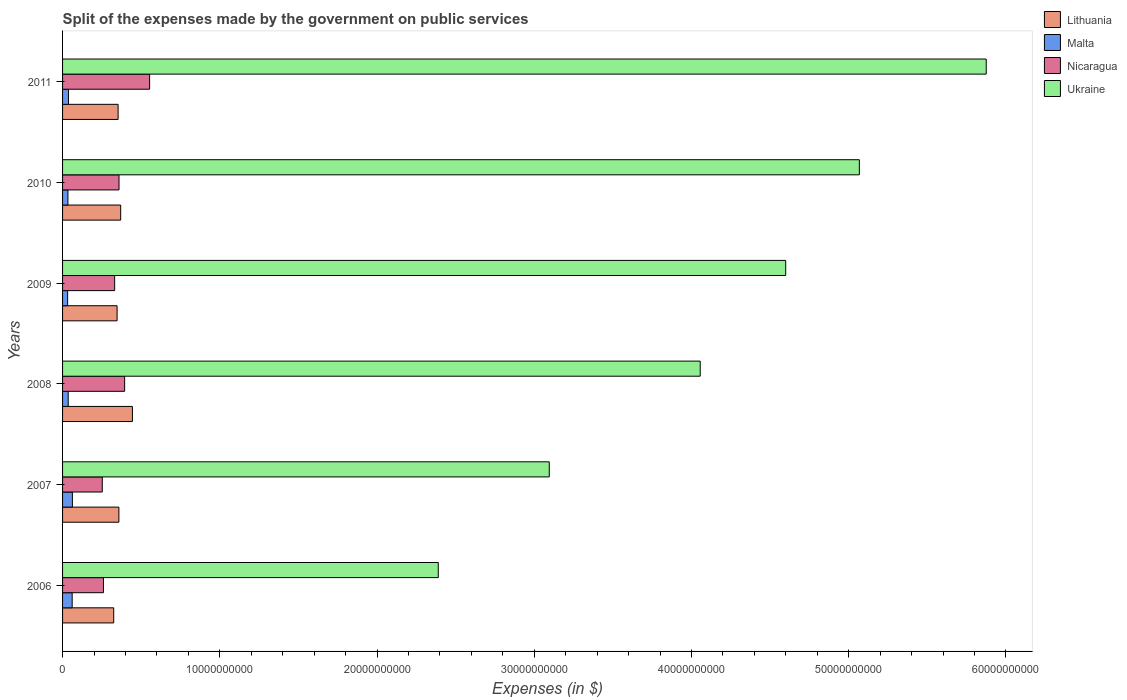How many different coloured bars are there?
Give a very brief answer. 4. Are the number of bars on each tick of the Y-axis equal?
Your answer should be compact. Yes. How many bars are there on the 2nd tick from the top?
Offer a very short reply. 4. What is the label of the 2nd group of bars from the top?
Offer a terse response. 2010. In how many cases, is the number of bars for a given year not equal to the number of legend labels?
Offer a terse response. 0. What is the expenses made by the government on public services in Lithuania in 2007?
Keep it short and to the point. 3.58e+09. Across all years, what is the maximum expenses made by the government on public services in Lithuania?
Provide a short and direct response. 4.44e+09. Across all years, what is the minimum expenses made by the government on public services in Lithuania?
Your answer should be compact. 3.25e+09. In which year was the expenses made by the government on public services in Lithuania minimum?
Offer a very short reply. 2006. What is the total expenses made by the government on public services in Malta in the graph?
Ensure brevity in your answer.  2.63e+09. What is the difference between the expenses made by the government on public services in Ukraine in 2008 and that in 2010?
Provide a short and direct response. -1.01e+1. What is the difference between the expenses made by the government on public services in Lithuania in 2010 and the expenses made by the government on public services in Malta in 2009?
Keep it short and to the point. 3.37e+09. What is the average expenses made by the government on public services in Nicaragua per year?
Provide a succinct answer. 3.59e+09. In the year 2007, what is the difference between the expenses made by the government on public services in Ukraine and expenses made by the government on public services in Malta?
Your answer should be very brief. 3.03e+1. In how many years, is the expenses made by the government on public services in Ukraine greater than 28000000000 $?
Your answer should be very brief. 5. What is the ratio of the expenses made by the government on public services in Ukraine in 2010 to that in 2011?
Ensure brevity in your answer.  0.86. Is the difference between the expenses made by the government on public services in Ukraine in 2010 and 2011 greater than the difference between the expenses made by the government on public services in Malta in 2010 and 2011?
Keep it short and to the point. No. What is the difference between the highest and the second highest expenses made by the government on public services in Nicaragua?
Ensure brevity in your answer.  1.59e+09. What is the difference between the highest and the lowest expenses made by the government on public services in Ukraine?
Ensure brevity in your answer.  3.49e+1. Is the sum of the expenses made by the government on public services in Nicaragua in 2010 and 2011 greater than the maximum expenses made by the government on public services in Malta across all years?
Make the answer very short. Yes. Is it the case that in every year, the sum of the expenses made by the government on public services in Lithuania and expenses made by the government on public services in Nicaragua is greater than the sum of expenses made by the government on public services in Ukraine and expenses made by the government on public services in Malta?
Keep it short and to the point. Yes. What does the 3rd bar from the top in 2007 represents?
Your response must be concise. Malta. What does the 3rd bar from the bottom in 2008 represents?
Ensure brevity in your answer.  Nicaragua. Is it the case that in every year, the sum of the expenses made by the government on public services in Nicaragua and expenses made by the government on public services in Malta is greater than the expenses made by the government on public services in Lithuania?
Offer a terse response. No. How many bars are there?
Provide a succinct answer. 24. Are all the bars in the graph horizontal?
Ensure brevity in your answer.  Yes. How many years are there in the graph?
Your answer should be very brief. 6. What is the difference between two consecutive major ticks on the X-axis?
Provide a succinct answer. 1.00e+1. Does the graph contain any zero values?
Your response must be concise. No. Does the graph contain grids?
Keep it short and to the point. No. How are the legend labels stacked?
Your answer should be compact. Vertical. What is the title of the graph?
Provide a succinct answer. Split of the expenses made by the government on public services. Does "Poland" appear as one of the legend labels in the graph?
Provide a short and direct response. No. What is the label or title of the X-axis?
Make the answer very short. Expenses (in $). What is the label or title of the Y-axis?
Provide a succinct answer. Years. What is the Expenses (in $) in Lithuania in 2006?
Offer a very short reply. 3.25e+09. What is the Expenses (in $) in Malta in 2006?
Keep it short and to the point. 6.11e+08. What is the Expenses (in $) of Nicaragua in 2006?
Keep it short and to the point. 2.60e+09. What is the Expenses (in $) in Ukraine in 2006?
Offer a terse response. 2.39e+1. What is the Expenses (in $) of Lithuania in 2007?
Offer a terse response. 3.58e+09. What is the Expenses (in $) in Malta in 2007?
Offer a very short reply. 6.25e+08. What is the Expenses (in $) in Nicaragua in 2007?
Your response must be concise. 2.53e+09. What is the Expenses (in $) of Ukraine in 2007?
Give a very brief answer. 3.10e+1. What is the Expenses (in $) in Lithuania in 2008?
Offer a terse response. 4.44e+09. What is the Expenses (in $) in Malta in 2008?
Ensure brevity in your answer.  3.59e+08. What is the Expenses (in $) of Nicaragua in 2008?
Keep it short and to the point. 3.95e+09. What is the Expenses (in $) of Ukraine in 2008?
Provide a succinct answer. 4.06e+1. What is the Expenses (in $) of Lithuania in 2009?
Your response must be concise. 3.47e+09. What is the Expenses (in $) in Malta in 2009?
Your answer should be very brief. 3.22e+08. What is the Expenses (in $) in Nicaragua in 2009?
Offer a very short reply. 3.31e+09. What is the Expenses (in $) of Ukraine in 2009?
Keep it short and to the point. 4.60e+1. What is the Expenses (in $) of Lithuania in 2010?
Provide a short and direct response. 3.70e+09. What is the Expenses (in $) of Malta in 2010?
Ensure brevity in your answer.  3.41e+08. What is the Expenses (in $) in Nicaragua in 2010?
Offer a very short reply. 3.59e+09. What is the Expenses (in $) of Ukraine in 2010?
Give a very brief answer. 5.07e+1. What is the Expenses (in $) of Lithuania in 2011?
Offer a terse response. 3.53e+09. What is the Expenses (in $) in Malta in 2011?
Offer a terse response. 3.76e+08. What is the Expenses (in $) of Nicaragua in 2011?
Your answer should be very brief. 5.54e+09. What is the Expenses (in $) of Ukraine in 2011?
Your answer should be very brief. 5.87e+1. Across all years, what is the maximum Expenses (in $) of Lithuania?
Make the answer very short. 4.44e+09. Across all years, what is the maximum Expenses (in $) of Malta?
Keep it short and to the point. 6.25e+08. Across all years, what is the maximum Expenses (in $) in Nicaragua?
Your answer should be compact. 5.54e+09. Across all years, what is the maximum Expenses (in $) of Ukraine?
Make the answer very short. 5.87e+1. Across all years, what is the minimum Expenses (in $) in Lithuania?
Your response must be concise. 3.25e+09. Across all years, what is the minimum Expenses (in $) in Malta?
Your answer should be compact. 3.22e+08. Across all years, what is the minimum Expenses (in $) of Nicaragua?
Your response must be concise. 2.53e+09. Across all years, what is the minimum Expenses (in $) in Ukraine?
Make the answer very short. 2.39e+1. What is the total Expenses (in $) in Lithuania in the graph?
Provide a short and direct response. 2.20e+1. What is the total Expenses (in $) in Malta in the graph?
Make the answer very short. 2.63e+09. What is the total Expenses (in $) in Nicaragua in the graph?
Your answer should be compact. 2.15e+1. What is the total Expenses (in $) in Ukraine in the graph?
Provide a succinct answer. 2.51e+11. What is the difference between the Expenses (in $) of Lithuania in 2006 and that in 2007?
Your response must be concise. -3.29e+08. What is the difference between the Expenses (in $) in Malta in 2006 and that in 2007?
Provide a short and direct response. -1.40e+07. What is the difference between the Expenses (in $) in Nicaragua in 2006 and that in 2007?
Provide a short and direct response. 7.43e+07. What is the difference between the Expenses (in $) of Ukraine in 2006 and that in 2007?
Give a very brief answer. -7.06e+09. What is the difference between the Expenses (in $) in Lithuania in 2006 and that in 2008?
Keep it short and to the point. -1.19e+09. What is the difference between the Expenses (in $) of Malta in 2006 and that in 2008?
Your answer should be compact. 2.52e+08. What is the difference between the Expenses (in $) in Nicaragua in 2006 and that in 2008?
Your response must be concise. -1.35e+09. What is the difference between the Expenses (in $) in Ukraine in 2006 and that in 2008?
Offer a terse response. -1.67e+1. What is the difference between the Expenses (in $) of Lithuania in 2006 and that in 2009?
Your answer should be compact. -2.15e+08. What is the difference between the Expenses (in $) in Malta in 2006 and that in 2009?
Give a very brief answer. 2.89e+08. What is the difference between the Expenses (in $) in Nicaragua in 2006 and that in 2009?
Give a very brief answer. -7.12e+08. What is the difference between the Expenses (in $) in Ukraine in 2006 and that in 2009?
Offer a very short reply. -2.21e+1. What is the difference between the Expenses (in $) in Lithuania in 2006 and that in 2010?
Give a very brief answer. -4.43e+08. What is the difference between the Expenses (in $) of Malta in 2006 and that in 2010?
Ensure brevity in your answer.  2.70e+08. What is the difference between the Expenses (in $) in Nicaragua in 2006 and that in 2010?
Provide a short and direct response. -9.89e+08. What is the difference between the Expenses (in $) of Ukraine in 2006 and that in 2010?
Provide a short and direct response. -2.68e+1. What is the difference between the Expenses (in $) of Lithuania in 2006 and that in 2011?
Ensure brevity in your answer.  -2.79e+08. What is the difference between the Expenses (in $) in Malta in 2006 and that in 2011?
Give a very brief answer. 2.35e+08. What is the difference between the Expenses (in $) of Nicaragua in 2006 and that in 2011?
Make the answer very short. -2.94e+09. What is the difference between the Expenses (in $) of Ukraine in 2006 and that in 2011?
Provide a short and direct response. -3.49e+1. What is the difference between the Expenses (in $) in Lithuania in 2007 and that in 2008?
Your answer should be very brief. -8.61e+08. What is the difference between the Expenses (in $) in Malta in 2007 and that in 2008?
Provide a succinct answer. 2.66e+08. What is the difference between the Expenses (in $) in Nicaragua in 2007 and that in 2008?
Keep it short and to the point. -1.42e+09. What is the difference between the Expenses (in $) in Ukraine in 2007 and that in 2008?
Offer a very short reply. -9.60e+09. What is the difference between the Expenses (in $) in Lithuania in 2007 and that in 2009?
Ensure brevity in your answer.  1.14e+08. What is the difference between the Expenses (in $) in Malta in 2007 and that in 2009?
Your answer should be very brief. 3.03e+08. What is the difference between the Expenses (in $) in Nicaragua in 2007 and that in 2009?
Ensure brevity in your answer.  -7.87e+08. What is the difference between the Expenses (in $) of Ukraine in 2007 and that in 2009?
Your response must be concise. -1.50e+1. What is the difference between the Expenses (in $) in Lithuania in 2007 and that in 2010?
Your answer should be very brief. -1.14e+08. What is the difference between the Expenses (in $) of Malta in 2007 and that in 2010?
Your answer should be compact. 2.84e+08. What is the difference between the Expenses (in $) of Nicaragua in 2007 and that in 2010?
Offer a terse response. -1.06e+09. What is the difference between the Expenses (in $) of Ukraine in 2007 and that in 2010?
Ensure brevity in your answer.  -1.97e+1. What is the difference between the Expenses (in $) in Lithuania in 2007 and that in 2011?
Provide a short and direct response. 4.96e+07. What is the difference between the Expenses (in $) in Malta in 2007 and that in 2011?
Offer a very short reply. 2.49e+08. What is the difference between the Expenses (in $) in Nicaragua in 2007 and that in 2011?
Make the answer very short. -3.01e+09. What is the difference between the Expenses (in $) in Ukraine in 2007 and that in 2011?
Provide a succinct answer. -2.78e+1. What is the difference between the Expenses (in $) of Lithuania in 2008 and that in 2009?
Provide a succinct answer. 9.76e+08. What is the difference between the Expenses (in $) in Malta in 2008 and that in 2009?
Give a very brief answer. 3.69e+07. What is the difference between the Expenses (in $) in Nicaragua in 2008 and that in 2009?
Keep it short and to the point. 6.34e+08. What is the difference between the Expenses (in $) in Ukraine in 2008 and that in 2009?
Give a very brief answer. -5.44e+09. What is the difference between the Expenses (in $) of Lithuania in 2008 and that in 2010?
Make the answer very short. 7.47e+08. What is the difference between the Expenses (in $) of Malta in 2008 and that in 2010?
Keep it short and to the point. 1.82e+07. What is the difference between the Expenses (in $) in Nicaragua in 2008 and that in 2010?
Keep it short and to the point. 3.57e+08. What is the difference between the Expenses (in $) in Ukraine in 2008 and that in 2010?
Provide a short and direct response. -1.01e+1. What is the difference between the Expenses (in $) of Lithuania in 2008 and that in 2011?
Provide a short and direct response. 9.11e+08. What is the difference between the Expenses (in $) in Malta in 2008 and that in 2011?
Make the answer very short. -1.72e+07. What is the difference between the Expenses (in $) in Nicaragua in 2008 and that in 2011?
Your response must be concise. -1.59e+09. What is the difference between the Expenses (in $) in Ukraine in 2008 and that in 2011?
Give a very brief answer. -1.82e+1. What is the difference between the Expenses (in $) in Lithuania in 2009 and that in 2010?
Keep it short and to the point. -2.29e+08. What is the difference between the Expenses (in $) of Malta in 2009 and that in 2010?
Provide a succinct answer. -1.87e+07. What is the difference between the Expenses (in $) of Nicaragua in 2009 and that in 2010?
Ensure brevity in your answer.  -2.77e+08. What is the difference between the Expenses (in $) of Ukraine in 2009 and that in 2010?
Offer a very short reply. -4.68e+09. What is the difference between the Expenses (in $) of Lithuania in 2009 and that in 2011?
Your response must be concise. -6.47e+07. What is the difference between the Expenses (in $) in Malta in 2009 and that in 2011?
Your response must be concise. -5.41e+07. What is the difference between the Expenses (in $) in Nicaragua in 2009 and that in 2011?
Ensure brevity in your answer.  -2.22e+09. What is the difference between the Expenses (in $) of Ukraine in 2009 and that in 2011?
Your response must be concise. -1.28e+1. What is the difference between the Expenses (in $) in Lithuania in 2010 and that in 2011?
Provide a short and direct response. 1.64e+08. What is the difference between the Expenses (in $) of Malta in 2010 and that in 2011?
Offer a terse response. -3.53e+07. What is the difference between the Expenses (in $) of Nicaragua in 2010 and that in 2011?
Give a very brief answer. -1.95e+09. What is the difference between the Expenses (in $) of Ukraine in 2010 and that in 2011?
Your response must be concise. -8.07e+09. What is the difference between the Expenses (in $) in Lithuania in 2006 and the Expenses (in $) in Malta in 2007?
Offer a terse response. 2.63e+09. What is the difference between the Expenses (in $) in Lithuania in 2006 and the Expenses (in $) in Nicaragua in 2007?
Give a very brief answer. 7.27e+08. What is the difference between the Expenses (in $) of Lithuania in 2006 and the Expenses (in $) of Ukraine in 2007?
Keep it short and to the point. -2.77e+1. What is the difference between the Expenses (in $) in Malta in 2006 and the Expenses (in $) in Nicaragua in 2007?
Provide a succinct answer. -1.92e+09. What is the difference between the Expenses (in $) in Malta in 2006 and the Expenses (in $) in Ukraine in 2007?
Your response must be concise. -3.03e+1. What is the difference between the Expenses (in $) of Nicaragua in 2006 and the Expenses (in $) of Ukraine in 2007?
Your answer should be compact. -2.84e+1. What is the difference between the Expenses (in $) in Lithuania in 2006 and the Expenses (in $) in Malta in 2008?
Provide a short and direct response. 2.89e+09. What is the difference between the Expenses (in $) in Lithuania in 2006 and the Expenses (in $) in Nicaragua in 2008?
Your answer should be compact. -6.94e+08. What is the difference between the Expenses (in $) in Lithuania in 2006 and the Expenses (in $) in Ukraine in 2008?
Provide a succinct answer. -3.73e+1. What is the difference between the Expenses (in $) of Malta in 2006 and the Expenses (in $) of Nicaragua in 2008?
Make the answer very short. -3.34e+09. What is the difference between the Expenses (in $) of Malta in 2006 and the Expenses (in $) of Ukraine in 2008?
Your answer should be very brief. -3.99e+1. What is the difference between the Expenses (in $) of Nicaragua in 2006 and the Expenses (in $) of Ukraine in 2008?
Give a very brief answer. -3.80e+1. What is the difference between the Expenses (in $) of Lithuania in 2006 and the Expenses (in $) of Malta in 2009?
Your response must be concise. 2.93e+09. What is the difference between the Expenses (in $) of Lithuania in 2006 and the Expenses (in $) of Nicaragua in 2009?
Your response must be concise. -5.99e+07. What is the difference between the Expenses (in $) of Lithuania in 2006 and the Expenses (in $) of Ukraine in 2009?
Ensure brevity in your answer.  -4.27e+1. What is the difference between the Expenses (in $) in Malta in 2006 and the Expenses (in $) in Nicaragua in 2009?
Your response must be concise. -2.70e+09. What is the difference between the Expenses (in $) of Malta in 2006 and the Expenses (in $) of Ukraine in 2009?
Provide a succinct answer. -4.54e+1. What is the difference between the Expenses (in $) of Nicaragua in 2006 and the Expenses (in $) of Ukraine in 2009?
Keep it short and to the point. -4.34e+1. What is the difference between the Expenses (in $) of Lithuania in 2006 and the Expenses (in $) of Malta in 2010?
Provide a short and direct response. 2.91e+09. What is the difference between the Expenses (in $) in Lithuania in 2006 and the Expenses (in $) in Nicaragua in 2010?
Give a very brief answer. -3.37e+08. What is the difference between the Expenses (in $) in Lithuania in 2006 and the Expenses (in $) in Ukraine in 2010?
Provide a short and direct response. -4.74e+1. What is the difference between the Expenses (in $) of Malta in 2006 and the Expenses (in $) of Nicaragua in 2010?
Offer a very short reply. -2.98e+09. What is the difference between the Expenses (in $) in Malta in 2006 and the Expenses (in $) in Ukraine in 2010?
Offer a terse response. -5.01e+1. What is the difference between the Expenses (in $) of Nicaragua in 2006 and the Expenses (in $) of Ukraine in 2010?
Your answer should be compact. -4.81e+1. What is the difference between the Expenses (in $) of Lithuania in 2006 and the Expenses (in $) of Malta in 2011?
Your response must be concise. 2.88e+09. What is the difference between the Expenses (in $) in Lithuania in 2006 and the Expenses (in $) in Nicaragua in 2011?
Offer a terse response. -2.28e+09. What is the difference between the Expenses (in $) of Lithuania in 2006 and the Expenses (in $) of Ukraine in 2011?
Your response must be concise. -5.55e+1. What is the difference between the Expenses (in $) in Malta in 2006 and the Expenses (in $) in Nicaragua in 2011?
Provide a succinct answer. -4.93e+09. What is the difference between the Expenses (in $) of Malta in 2006 and the Expenses (in $) of Ukraine in 2011?
Provide a succinct answer. -5.81e+1. What is the difference between the Expenses (in $) of Nicaragua in 2006 and the Expenses (in $) of Ukraine in 2011?
Your answer should be very brief. -5.61e+1. What is the difference between the Expenses (in $) of Lithuania in 2007 and the Expenses (in $) of Malta in 2008?
Provide a short and direct response. 3.22e+09. What is the difference between the Expenses (in $) of Lithuania in 2007 and the Expenses (in $) of Nicaragua in 2008?
Offer a terse response. -3.65e+08. What is the difference between the Expenses (in $) of Lithuania in 2007 and the Expenses (in $) of Ukraine in 2008?
Your answer should be compact. -3.70e+1. What is the difference between the Expenses (in $) of Malta in 2007 and the Expenses (in $) of Nicaragua in 2008?
Offer a very short reply. -3.32e+09. What is the difference between the Expenses (in $) in Malta in 2007 and the Expenses (in $) in Ukraine in 2008?
Offer a very short reply. -3.99e+1. What is the difference between the Expenses (in $) of Nicaragua in 2007 and the Expenses (in $) of Ukraine in 2008?
Keep it short and to the point. -3.80e+1. What is the difference between the Expenses (in $) of Lithuania in 2007 and the Expenses (in $) of Malta in 2009?
Provide a short and direct response. 3.26e+09. What is the difference between the Expenses (in $) of Lithuania in 2007 and the Expenses (in $) of Nicaragua in 2009?
Provide a short and direct response. 2.69e+08. What is the difference between the Expenses (in $) in Lithuania in 2007 and the Expenses (in $) in Ukraine in 2009?
Ensure brevity in your answer.  -4.24e+1. What is the difference between the Expenses (in $) of Malta in 2007 and the Expenses (in $) of Nicaragua in 2009?
Keep it short and to the point. -2.69e+09. What is the difference between the Expenses (in $) in Malta in 2007 and the Expenses (in $) in Ukraine in 2009?
Offer a terse response. -4.54e+1. What is the difference between the Expenses (in $) of Nicaragua in 2007 and the Expenses (in $) of Ukraine in 2009?
Ensure brevity in your answer.  -4.35e+1. What is the difference between the Expenses (in $) in Lithuania in 2007 and the Expenses (in $) in Malta in 2010?
Provide a short and direct response. 3.24e+09. What is the difference between the Expenses (in $) in Lithuania in 2007 and the Expenses (in $) in Nicaragua in 2010?
Give a very brief answer. -8.19e+06. What is the difference between the Expenses (in $) of Lithuania in 2007 and the Expenses (in $) of Ukraine in 2010?
Your response must be concise. -4.71e+1. What is the difference between the Expenses (in $) in Malta in 2007 and the Expenses (in $) in Nicaragua in 2010?
Your answer should be compact. -2.97e+09. What is the difference between the Expenses (in $) of Malta in 2007 and the Expenses (in $) of Ukraine in 2010?
Your answer should be very brief. -5.01e+1. What is the difference between the Expenses (in $) in Nicaragua in 2007 and the Expenses (in $) in Ukraine in 2010?
Offer a very short reply. -4.82e+1. What is the difference between the Expenses (in $) of Lithuania in 2007 and the Expenses (in $) of Malta in 2011?
Your response must be concise. 3.21e+09. What is the difference between the Expenses (in $) of Lithuania in 2007 and the Expenses (in $) of Nicaragua in 2011?
Your response must be concise. -1.96e+09. What is the difference between the Expenses (in $) of Lithuania in 2007 and the Expenses (in $) of Ukraine in 2011?
Ensure brevity in your answer.  -5.52e+1. What is the difference between the Expenses (in $) of Malta in 2007 and the Expenses (in $) of Nicaragua in 2011?
Ensure brevity in your answer.  -4.91e+09. What is the difference between the Expenses (in $) in Malta in 2007 and the Expenses (in $) in Ukraine in 2011?
Give a very brief answer. -5.81e+1. What is the difference between the Expenses (in $) in Nicaragua in 2007 and the Expenses (in $) in Ukraine in 2011?
Give a very brief answer. -5.62e+1. What is the difference between the Expenses (in $) of Lithuania in 2008 and the Expenses (in $) of Malta in 2009?
Your answer should be compact. 4.12e+09. What is the difference between the Expenses (in $) of Lithuania in 2008 and the Expenses (in $) of Nicaragua in 2009?
Your answer should be very brief. 1.13e+09. What is the difference between the Expenses (in $) in Lithuania in 2008 and the Expenses (in $) in Ukraine in 2009?
Your response must be concise. -4.16e+1. What is the difference between the Expenses (in $) in Malta in 2008 and the Expenses (in $) in Nicaragua in 2009?
Give a very brief answer. -2.95e+09. What is the difference between the Expenses (in $) of Malta in 2008 and the Expenses (in $) of Ukraine in 2009?
Make the answer very short. -4.56e+1. What is the difference between the Expenses (in $) in Nicaragua in 2008 and the Expenses (in $) in Ukraine in 2009?
Offer a terse response. -4.20e+1. What is the difference between the Expenses (in $) of Lithuania in 2008 and the Expenses (in $) of Malta in 2010?
Give a very brief answer. 4.10e+09. What is the difference between the Expenses (in $) in Lithuania in 2008 and the Expenses (in $) in Nicaragua in 2010?
Keep it short and to the point. 8.53e+08. What is the difference between the Expenses (in $) in Lithuania in 2008 and the Expenses (in $) in Ukraine in 2010?
Make the answer very short. -4.62e+1. What is the difference between the Expenses (in $) in Malta in 2008 and the Expenses (in $) in Nicaragua in 2010?
Offer a very short reply. -3.23e+09. What is the difference between the Expenses (in $) in Malta in 2008 and the Expenses (in $) in Ukraine in 2010?
Your response must be concise. -5.03e+1. What is the difference between the Expenses (in $) of Nicaragua in 2008 and the Expenses (in $) of Ukraine in 2010?
Your response must be concise. -4.67e+1. What is the difference between the Expenses (in $) of Lithuania in 2008 and the Expenses (in $) of Malta in 2011?
Offer a terse response. 4.07e+09. What is the difference between the Expenses (in $) in Lithuania in 2008 and the Expenses (in $) in Nicaragua in 2011?
Provide a succinct answer. -1.09e+09. What is the difference between the Expenses (in $) of Lithuania in 2008 and the Expenses (in $) of Ukraine in 2011?
Your answer should be compact. -5.43e+1. What is the difference between the Expenses (in $) in Malta in 2008 and the Expenses (in $) in Nicaragua in 2011?
Ensure brevity in your answer.  -5.18e+09. What is the difference between the Expenses (in $) of Malta in 2008 and the Expenses (in $) of Ukraine in 2011?
Keep it short and to the point. -5.84e+1. What is the difference between the Expenses (in $) of Nicaragua in 2008 and the Expenses (in $) of Ukraine in 2011?
Your answer should be compact. -5.48e+1. What is the difference between the Expenses (in $) of Lithuania in 2009 and the Expenses (in $) of Malta in 2010?
Give a very brief answer. 3.13e+09. What is the difference between the Expenses (in $) of Lithuania in 2009 and the Expenses (in $) of Nicaragua in 2010?
Make the answer very short. -1.22e+08. What is the difference between the Expenses (in $) of Lithuania in 2009 and the Expenses (in $) of Ukraine in 2010?
Provide a succinct answer. -4.72e+1. What is the difference between the Expenses (in $) of Malta in 2009 and the Expenses (in $) of Nicaragua in 2010?
Give a very brief answer. -3.27e+09. What is the difference between the Expenses (in $) of Malta in 2009 and the Expenses (in $) of Ukraine in 2010?
Ensure brevity in your answer.  -5.04e+1. What is the difference between the Expenses (in $) of Nicaragua in 2009 and the Expenses (in $) of Ukraine in 2010?
Provide a succinct answer. -4.74e+1. What is the difference between the Expenses (in $) of Lithuania in 2009 and the Expenses (in $) of Malta in 2011?
Provide a succinct answer. 3.09e+09. What is the difference between the Expenses (in $) in Lithuania in 2009 and the Expenses (in $) in Nicaragua in 2011?
Your answer should be compact. -2.07e+09. What is the difference between the Expenses (in $) in Lithuania in 2009 and the Expenses (in $) in Ukraine in 2011?
Provide a short and direct response. -5.53e+1. What is the difference between the Expenses (in $) of Malta in 2009 and the Expenses (in $) of Nicaragua in 2011?
Keep it short and to the point. -5.22e+09. What is the difference between the Expenses (in $) in Malta in 2009 and the Expenses (in $) in Ukraine in 2011?
Keep it short and to the point. -5.84e+1. What is the difference between the Expenses (in $) in Nicaragua in 2009 and the Expenses (in $) in Ukraine in 2011?
Ensure brevity in your answer.  -5.54e+1. What is the difference between the Expenses (in $) of Lithuania in 2010 and the Expenses (in $) of Malta in 2011?
Provide a succinct answer. 3.32e+09. What is the difference between the Expenses (in $) in Lithuania in 2010 and the Expenses (in $) in Nicaragua in 2011?
Ensure brevity in your answer.  -1.84e+09. What is the difference between the Expenses (in $) in Lithuania in 2010 and the Expenses (in $) in Ukraine in 2011?
Your answer should be compact. -5.51e+1. What is the difference between the Expenses (in $) of Malta in 2010 and the Expenses (in $) of Nicaragua in 2011?
Offer a very short reply. -5.20e+09. What is the difference between the Expenses (in $) in Malta in 2010 and the Expenses (in $) in Ukraine in 2011?
Offer a very short reply. -5.84e+1. What is the difference between the Expenses (in $) of Nicaragua in 2010 and the Expenses (in $) of Ukraine in 2011?
Offer a terse response. -5.52e+1. What is the average Expenses (in $) in Lithuania per year?
Offer a terse response. 3.66e+09. What is the average Expenses (in $) of Malta per year?
Offer a very short reply. 4.39e+08. What is the average Expenses (in $) in Nicaragua per year?
Give a very brief answer. 3.59e+09. What is the average Expenses (in $) of Ukraine per year?
Your answer should be very brief. 4.18e+1. In the year 2006, what is the difference between the Expenses (in $) in Lithuania and Expenses (in $) in Malta?
Your answer should be compact. 2.64e+09. In the year 2006, what is the difference between the Expenses (in $) in Lithuania and Expenses (in $) in Nicaragua?
Your response must be concise. 6.52e+08. In the year 2006, what is the difference between the Expenses (in $) of Lithuania and Expenses (in $) of Ukraine?
Ensure brevity in your answer.  -2.06e+1. In the year 2006, what is the difference between the Expenses (in $) of Malta and Expenses (in $) of Nicaragua?
Give a very brief answer. -1.99e+09. In the year 2006, what is the difference between the Expenses (in $) of Malta and Expenses (in $) of Ukraine?
Offer a terse response. -2.33e+1. In the year 2006, what is the difference between the Expenses (in $) of Nicaragua and Expenses (in $) of Ukraine?
Ensure brevity in your answer.  -2.13e+1. In the year 2007, what is the difference between the Expenses (in $) of Lithuania and Expenses (in $) of Malta?
Your answer should be compact. 2.96e+09. In the year 2007, what is the difference between the Expenses (in $) of Lithuania and Expenses (in $) of Nicaragua?
Provide a succinct answer. 1.06e+09. In the year 2007, what is the difference between the Expenses (in $) in Lithuania and Expenses (in $) in Ukraine?
Your answer should be compact. -2.74e+1. In the year 2007, what is the difference between the Expenses (in $) of Malta and Expenses (in $) of Nicaragua?
Provide a succinct answer. -1.90e+09. In the year 2007, what is the difference between the Expenses (in $) in Malta and Expenses (in $) in Ukraine?
Ensure brevity in your answer.  -3.03e+1. In the year 2007, what is the difference between the Expenses (in $) in Nicaragua and Expenses (in $) in Ukraine?
Keep it short and to the point. -2.84e+1. In the year 2008, what is the difference between the Expenses (in $) of Lithuania and Expenses (in $) of Malta?
Provide a short and direct response. 4.08e+09. In the year 2008, what is the difference between the Expenses (in $) in Lithuania and Expenses (in $) in Nicaragua?
Provide a short and direct response. 4.96e+08. In the year 2008, what is the difference between the Expenses (in $) of Lithuania and Expenses (in $) of Ukraine?
Offer a very short reply. -3.61e+1. In the year 2008, what is the difference between the Expenses (in $) of Malta and Expenses (in $) of Nicaragua?
Your response must be concise. -3.59e+09. In the year 2008, what is the difference between the Expenses (in $) of Malta and Expenses (in $) of Ukraine?
Provide a short and direct response. -4.02e+1. In the year 2008, what is the difference between the Expenses (in $) of Nicaragua and Expenses (in $) of Ukraine?
Provide a succinct answer. -3.66e+1. In the year 2009, what is the difference between the Expenses (in $) of Lithuania and Expenses (in $) of Malta?
Ensure brevity in your answer.  3.15e+09. In the year 2009, what is the difference between the Expenses (in $) in Lithuania and Expenses (in $) in Nicaragua?
Give a very brief answer. 1.55e+08. In the year 2009, what is the difference between the Expenses (in $) in Lithuania and Expenses (in $) in Ukraine?
Offer a terse response. -4.25e+1. In the year 2009, what is the difference between the Expenses (in $) of Malta and Expenses (in $) of Nicaragua?
Provide a succinct answer. -2.99e+09. In the year 2009, what is the difference between the Expenses (in $) of Malta and Expenses (in $) of Ukraine?
Offer a very short reply. -4.57e+1. In the year 2009, what is the difference between the Expenses (in $) of Nicaragua and Expenses (in $) of Ukraine?
Your answer should be compact. -4.27e+1. In the year 2010, what is the difference between the Expenses (in $) of Lithuania and Expenses (in $) of Malta?
Offer a very short reply. 3.36e+09. In the year 2010, what is the difference between the Expenses (in $) in Lithuania and Expenses (in $) in Nicaragua?
Offer a very short reply. 1.06e+08. In the year 2010, what is the difference between the Expenses (in $) of Lithuania and Expenses (in $) of Ukraine?
Your answer should be compact. -4.70e+1. In the year 2010, what is the difference between the Expenses (in $) in Malta and Expenses (in $) in Nicaragua?
Provide a short and direct response. -3.25e+09. In the year 2010, what is the difference between the Expenses (in $) in Malta and Expenses (in $) in Ukraine?
Offer a very short reply. -5.03e+1. In the year 2010, what is the difference between the Expenses (in $) of Nicaragua and Expenses (in $) of Ukraine?
Keep it short and to the point. -4.71e+1. In the year 2011, what is the difference between the Expenses (in $) of Lithuania and Expenses (in $) of Malta?
Offer a terse response. 3.16e+09. In the year 2011, what is the difference between the Expenses (in $) of Lithuania and Expenses (in $) of Nicaragua?
Your response must be concise. -2.01e+09. In the year 2011, what is the difference between the Expenses (in $) of Lithuania and Expenses (in $) of Ukraine?
Provide a succinct answer. -5.52e+1. In the year 2011, what is the difference between the Expenses (in $) of Malta and Expenses (in $) of Nicaragua?
Make the answer very short. -5.16e+09. In the year 2011, what is the difference between the Expenses (in $) of Malta and Expenses (in $) of Ukraine?
Make the answer very short. -5.84e+1. In the year 2011, what is the difference between the Expenses (in $) in Nicaragua and Expenses (in $) in Ukraine?
Provide a short and direct response. -5.32e+1. What is the ratio of the Expenses (in $) in Lithuania in 2006 to that in 2007?
Offer a terse response. 0.91. What is the ratio of the Expenses (in $) of Malta in 2006 to that in 2007?
Ensure brevity in your answer.  0.98. What is the ratio of the Expenses (in $) in Nicaragua in 2006 to that in 2007?
Provide a short and direct response. 1.03. What is the ratio of the Expenses (in $) of Ukraine in 2006 to that in 2007?
Provide a short and direct response. 0.77. What is the ratio of the Expenses (in $) in Lithuania in 2006 to that in 2008?
Ensure brevity in your answer.  0.73. What is the ratio of the Expenses (in $) of Malta in 2006 to that in 2008?
Ensure brevity in your answer.  1.7. What is the ratio of the Expenses (in $) in Nicaragua in 2006 to that in 2008?
Offer a very short reply. 0.66. What is the ratio of the Expenses (in $) in Ukraine in 2006 to that in 2008?
Keep it short and to the point. 0.59. What is the ratio of the Expenses (in $) in Lithuania in 2006 to that in 2009?
Ensure brevity in your answer.  0.94. What is the ratio of the Expenses (in $) of Malta in 2006 to that in 2009?
Ensure brevity in your answer.  1.9. What is the ratio of the Expenses (in $) in Nicaragua in 2006 to that in 2009?
Your answer should be very brief. 0.79. What is the ratio of the Expenses (in $) of Ukraine in 2006 to that in 2009?
Keep it short and to the point. 0.52. What is the ratio of the Expenses (in $) in Lithuania in 2006 to that in 2010?
Make the answer very short. 0.88. What is the ratio of the Expenses (in $) of Malta in 2006 to that in 2010?
Provide a short and direct response. 1.79. What is the ratio of the Expenses (in $) of Nicaragua in 2006 to that in 2010?
Make the answer very short. 0.72. What is the ratio of the Expenses (in $) in Ukraine in 2006 to that in 2010?
Give a very brief answer. 0.47. What is the ratio of the Expenses (in $) of Lithuania in 2006 to that in 2011?
Provide a short and direct response. 0.92. What is the ratio of the Expenses (in $) of Malta in 2006 to that in 2011?
Offer a very short reply. 1.62. What is the ratio of the Expenses (in $) in Nicaragua in 2006 to that in 2011?
Make the answer very short. 0.47. What is the ratio of the Expenses (in $) in Ukraine in 2006 to that in 2011?
Make the answer very short. 0.41. What is the ratio of the Expenses (in $) of Lithuania in 2007 to that in 2008?
Provide a succinct answer. 0.81. What is the ratio of the Expenses (in $) of Malta in 2007 to that in 2008?
Give a very brief answer. 1.74. What is the ratio of the Expenses (in $) of Nicaragua in 2007 to that in 2008?
Keep it short and to the point. 0.64. What is the ratio of the Expenses (in $) in Ukraine in 2007 to that in 2008?
Offer a terse response. 0.76. What is the ratio of the Expenses (in $) in Lithuania in 2007 to that in 2009?
Give a very brief answer. 1.03. What is the ratio of the Expenses (in $) of Malta in 2007 to that in 2009?
Make the answer very short. 1.94. What is the ratio of the Expenses (in $) of Nicaragua in 2007 to that in 2009?
Make the answer very short. 0.76. What is the ratio of the Expenses (in $) in Ukraine in 2007 to that in 2009?
Provide a short and direct response. 0.67. What is the ratio of the Expenses (in $) in Lithuania in 2007 to that in 2010?
Your answer should be very brief. 0.97. What is the ratio of the Expenses (in $) of Malta in 2007 to that in 2010?
Your answer should be very brief. 1.83. What is the ratio of the Expenses (in $) in Nicaragua in 2007 to that in 2010?
Provide a short and direct response. 0.7. What is the ratio of the Expenses (in $) in Ukraine in 2007 to that in 2010?
Offer a very short reply. 0.61. What is the ratio of the Expenses (in $) of Lithuania in 2007 to that in 2011?
Your response must be concise. 1.01. What is the ratio of the Expenses (in $) of Malta in 2007 to that in 2011?
Offer a terse response. 1.66. What is the ratio of the Expenses (in $) in Nicaragua in 2007 to that in 2011?
Offer a very short reply. 0.46. What is the ratio of the Expenses (in $) in Ukraine in 2007 to that in 2011?
Your answer should be compact. 0.53. What is the ratio of the Expenses (in $) of Lithuania in 2008 to that in 2009?
Make the answer very short. 1.28. What is the ratio of the Expenses (in $) in Malta in 2008 to that in 2009?
Your answer should be compact. 1.11. What is the ratio of the Expenses (in $) in Nicaragua in 2008 to that in 2009?
Your answer should be compact. 1.19. What is the ratio of the Expenses (in $) in Ukraine in 2008 to that in 2009?
Your answer should be compact. 0.88. What is the ratio of the Expenses (in $) in Lithuania in 2008 to that in 2010?
Provide a succinct answer. 1.2. What is the ratio of the Expenses (in $) in Malta in 2008 to that in 2010?
Keep it short and to the point. 1.05. What is the ratio of the Expenses (in $) of Nicaragua in 2008 to that in 2010?
Provide a short and direct response. 1.1. What is the ratio of the Expenses (in $) of Ukraine in 2008 to that in 2010?
Provide a succinct answer. 0.8. What is the ratio of the Expenses (in $) in Lithuania in 2008 to that in 2011?
Your answer should be very brief. 1.26. What is the ratio of the Expenses (in $) of Malta in 2008 to that in 2011?
Your response must be concise. 0.95. What is the ratio of the Expenses (in $) of Nicaragua in 2008 to that in 2011?
Your response must be concise. 0.71. What is the ratio of the Expenses (in $) in Ukraine in 2008 to that in 2011?
Your answer should be compact. 0.69. What is the ratio of the Expenses (in $) of Lithuania in 2009 to that in 2010?
Your answer should be compact. 0.94. What is the ratio of the Expenses (in $) in Malta in 2009 to that in 2010?
Your answer should be compact. 0.95. What is the ratio of the Expenses (in $) in Nicaragua in 2009 to that in 2010?
Offer a very short reply. 0.92. What is the ratio of the Expenses (in $) of Ukraine in 2009 to that in 2010?
Offer a very short reply. 0.91. What is the ratio of the Expenses (in $) of Lithuania in 2009 to that in 2011?
Ensure brevity in your answer.  0.98. What is the ratio of the Expenses (in $) in Malta in 2009 to that in 2011?
Make the answer very short. 0.86. What is the ratio of the Expenses (in $) of Nicaragua in 2009 to that in 2011?
Provide a succinct answer. 0.6. What is the ratio of the Expenses (in $) of Ukraine in 2009 to that in 2011?
Offer a terse response. 0.78. What is the ratio of the Expenses (in $) in Lithuania in 2010 to that in 2011?
Provide a short and direct response. 1.05. What is the ratio of the Expenses (in $) in Malta in 2010 to that in 2011?
Your response must be concise. 0.91. What is the ratio of the Expenses (in $) in Nicaragua in 2010 to that in 2011?
Your response must be concise. 0.65. What is the ratio of the Expenses (in $) in Ukraine in 2010 to that in 2011?
Make the answer very short. 0.86. What is the difference between the highest and the second highest Expenses (in $) of Lithuania?
Your answer should be very brief. 7.47e+08. What is the difference between the highest and the second highest Expenses (in $) in Malta?
Your answer should be very brief. 1.40e+07. What is the difference between the highest and the second highest Expenses (in $) in Nicaragua?
Offer a very short reply. 1.59e+09. What is the difference between the highest and the second highest Expenses (in $) of Ukraine?
Make the answer very short. 8.07e+09. What is the difference between the highest and the lowest Expenses (in $) of Lithuania?
Keep it short and to the point. 1.19e+09. What is the difference between the highest and the lowest Expenses (in $) in Malta?
Offer a terse response. 3.03e+08. What is the difference between the highest and the lowest Expenses (in $) of Nicaragua?
Your answer should be very brief. 3.01e+09. What is the difference between the highest and the lowest Expenses (in $) in Ukraine?
Your answer should be very brief. 3.49e+1. 